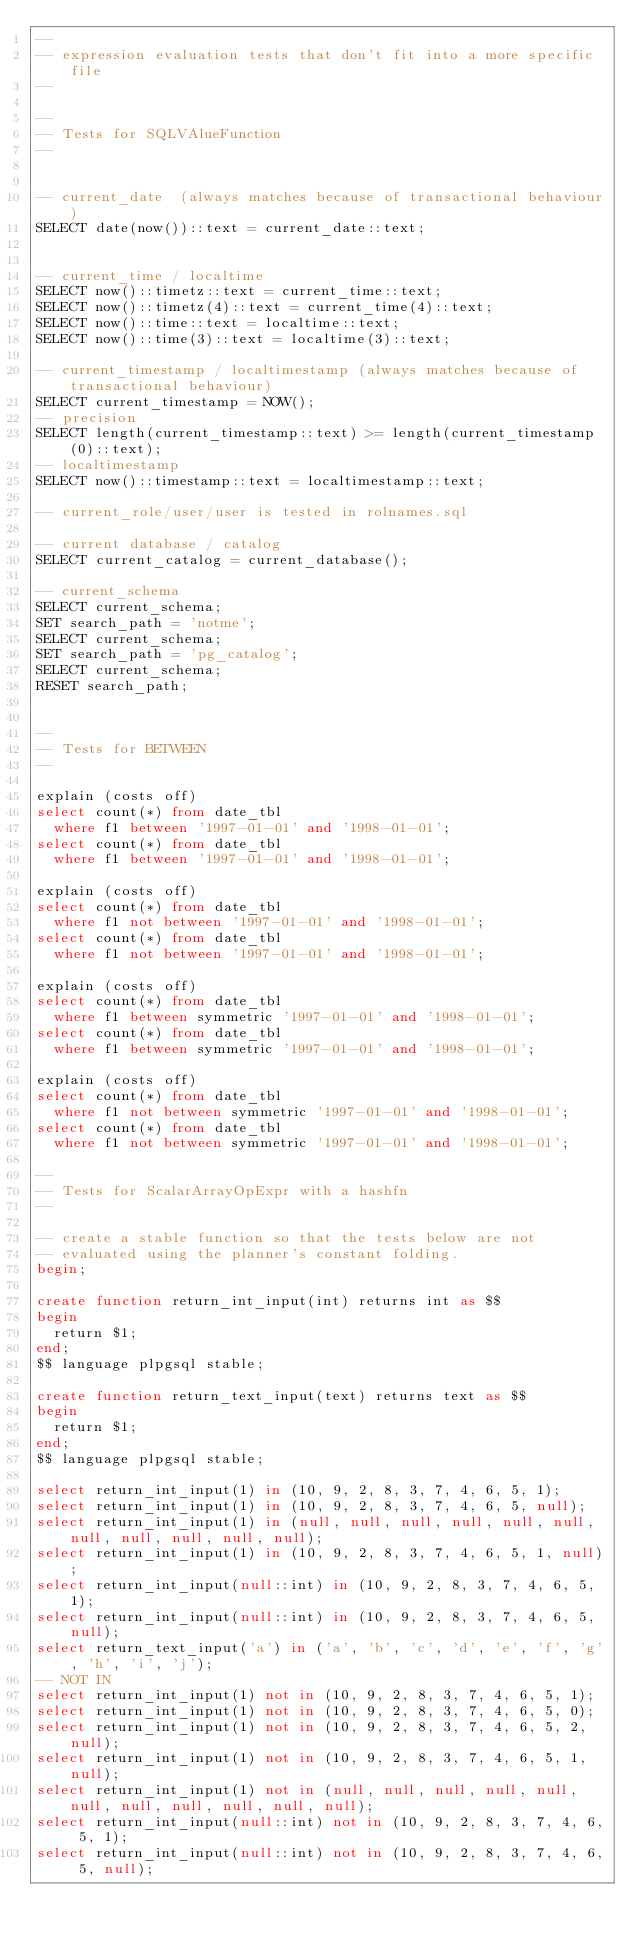<code> <loc_0><loc_0><loc_500><loc_500><_SQL_>--
-- expression evaluation tests that don't fit into a more specific file
--

--
-- Tests for SQLVAlueFunction
--


-- current_date  (always matches because of transactional behaviour)
SELECT date(now())::text = current_date::text;


-- current_time / localtime
SELECT now()::timetz::text = current_time::text;
SELECT now()::timetz(4)::text = current_time(4)::text;
SELECT now()::time::text = localtime::text;
SELECT now()::time(3)::text = localtime(3)::text;

-- current_timestamp / localtimestamp (always matches because of transactional behaviour)
SELECT current_timestamp = NOW();
-- precision
SELECT length(current_timestamp::text) >= length(current_timestamp(0)::text);
-- localtimestamp
SELECT now()::timestamp::text = localtimestamp::text;

-- current_role/user/user is tested in rolnames.sql

-- current database / catalog
SELECT current_catalog = current_database();

-- current_schema
SELECT current_schema;
SET search_path = 'notme';
SELECT current_schema;
SET search_path = 'pg_catalog';
SELECT current_schema;
RESET search_path;


--
-- Tests for BETWEEN
--

explain (costs off)
select count(*) from date_tbl
  where f1 between '1997-01-01' and '1998-01-01';
select count(*) from date_tbl
  where f1 between '1997-01-01' and '1998-01-01';

explain (costs off)
select count(*) from date_tbl
  where f1 not between '1997-01-01' and '1998-01-01';
select count(*) from date_tbl
  where f1 not between '1997-01-01' and '1998-01-01';

explain (costs off)
select count(*) from date_tbl
  where f1 between symmetric '1997-01-01' and '1998-01-01';
select count(*) from date_tbl
  where f1 between symmetric '1997-01-01' and '1998-01-01';

explain (costs off)
select count(*) from date_tbl
  where f1 not between symmetric '1997-01-01' and '1998-01-01';
select count(*) from date_tbl
  where f1 not between symmetric '1997-01-01' and '1998-01-01';

--
-- Tests for ScalarArrayOpExpr with a hashfn
--

-- create a stable function so that the tests below are not
-- evaluated using the planner's constant folding.
begin;

create function return_int_input(int) returns int as $$
begin
	return $1;
end;
$$ language plpgsql stable;

create function return_text_input(text) returns text as $$
begin
	return $1;
end;
$$ language plpgsql stable;

select return_int_input(1) in (10, 9, 2, 8, 3, 7, 4, 6, 5, 1);
select return_int_input(1) in (10, 9, 2, 8, 3, 7, 4, 6, 5, null);
select return_int_input(1) in (null, null, null, null, null, null, null, null, null, null, null);
select return_int_input(1) in (10, 9, 2, 8, 3, 7, 4, 6, 5, 1, null);
select return_int_input(null::int) in (10, 9, 2, 8, 3, 7, 4, 6, 5, 1);
select return_int_input(null::int) in (10, 9, 2, 8, 3, 7, 4, 6, 5, null);
select return_text_input('a') in ('a', 'b', 'c', 'd', 'e', 'f', 'g', 'h', 'i', 'j');
-- NOT IN
select return_int_input(1) not in (10, 9, 2, 8, 3, 7, 4, 6, 5, 1);
select return_int_input(1) not in (10, 9, 2, 8, 3, 7, 4, 6, 5, 0);
select return_int_input(1) not in (10, 9, 2, 8, 3, 7, 4, 6, 5, 2, null);
select return_int_input(1) not in (10, 9, 2, 8, 3, 7, 4, 6, 5, 1, null);
select return_int_input(1) not in (null, null, null, null, null, null, null, null, null, null, null);
select return_int_input(null::int) not in (10, 9, 2, 8, 3, 7, 4, 6, 5, 1);
select return_int_input(null::int) not in (10, 9, 2, 8, 3, 7, 4, 6, 5, null);</code> 